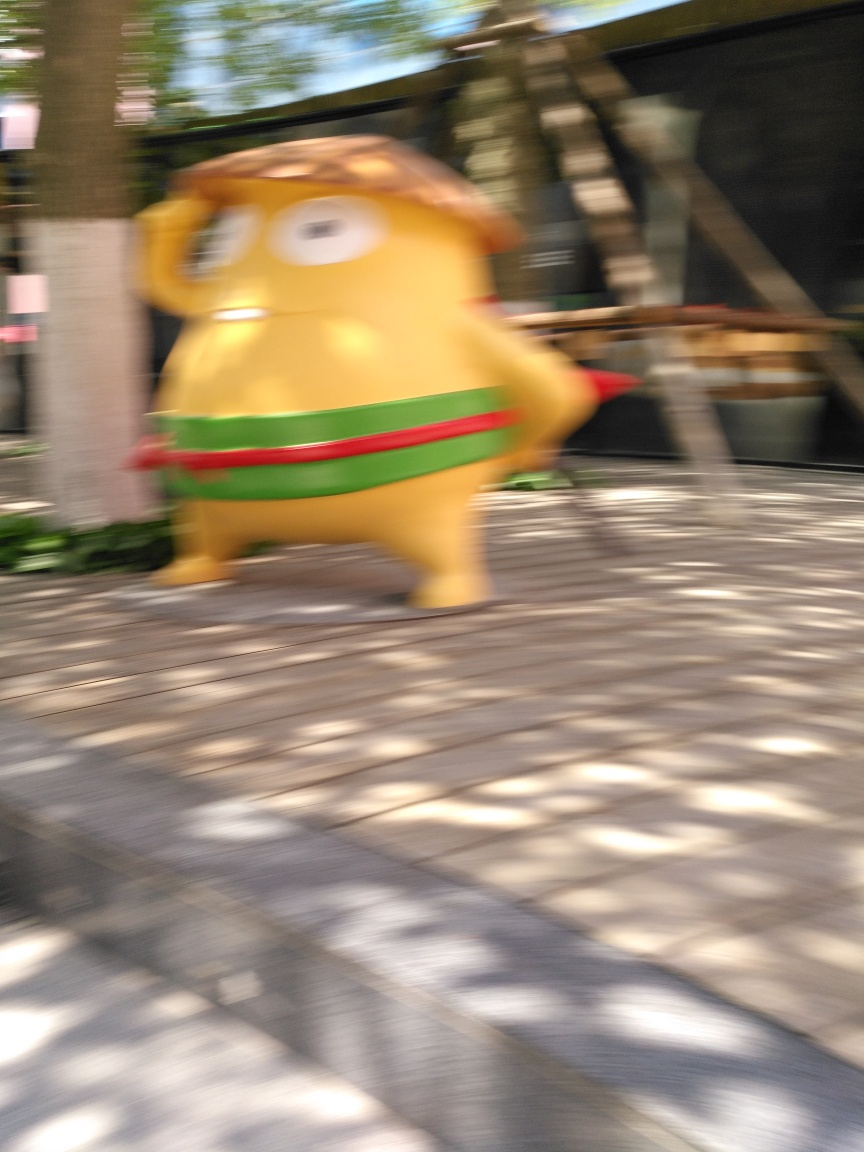Can you describe the setting of this image? The setting appears to be an urban outdoor area with a modern design, possibly a plaza or pedestrian walkway. The combination of trees, structured pavement, and what seems to be part of a building in the background gives it a contemporary, public space vibe. What atmosphere does the blurred image convey? The blurred quality of the image conveys a sense of movement and rush, almost as if capturing a fleeting moment. It imparts a dynamic feel, potentially evoking emotions related to haste, excitement, or even chaos. 